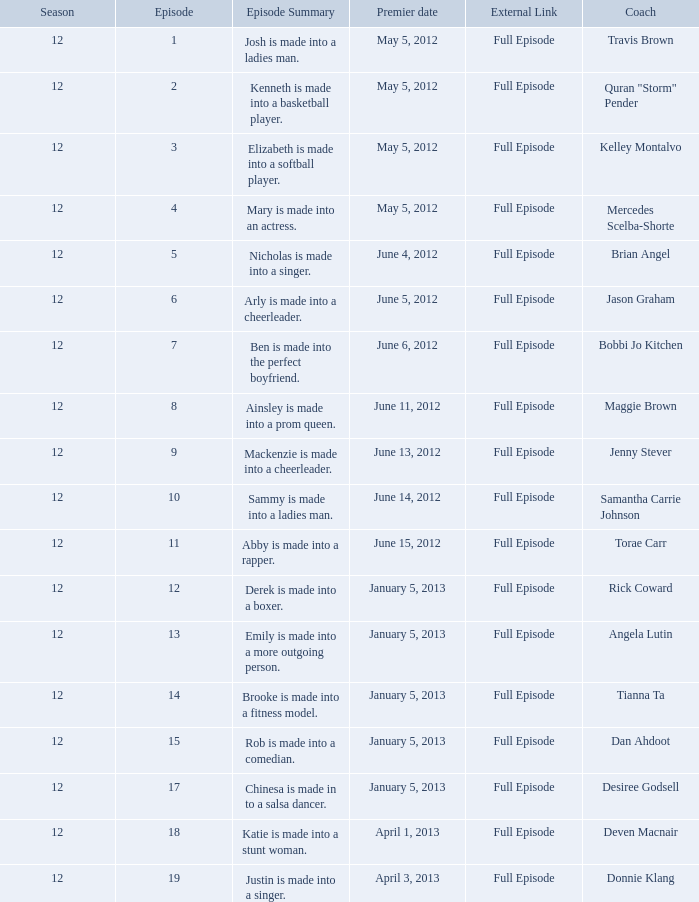Which episode has the least significance for donnie klang? 19.0. 